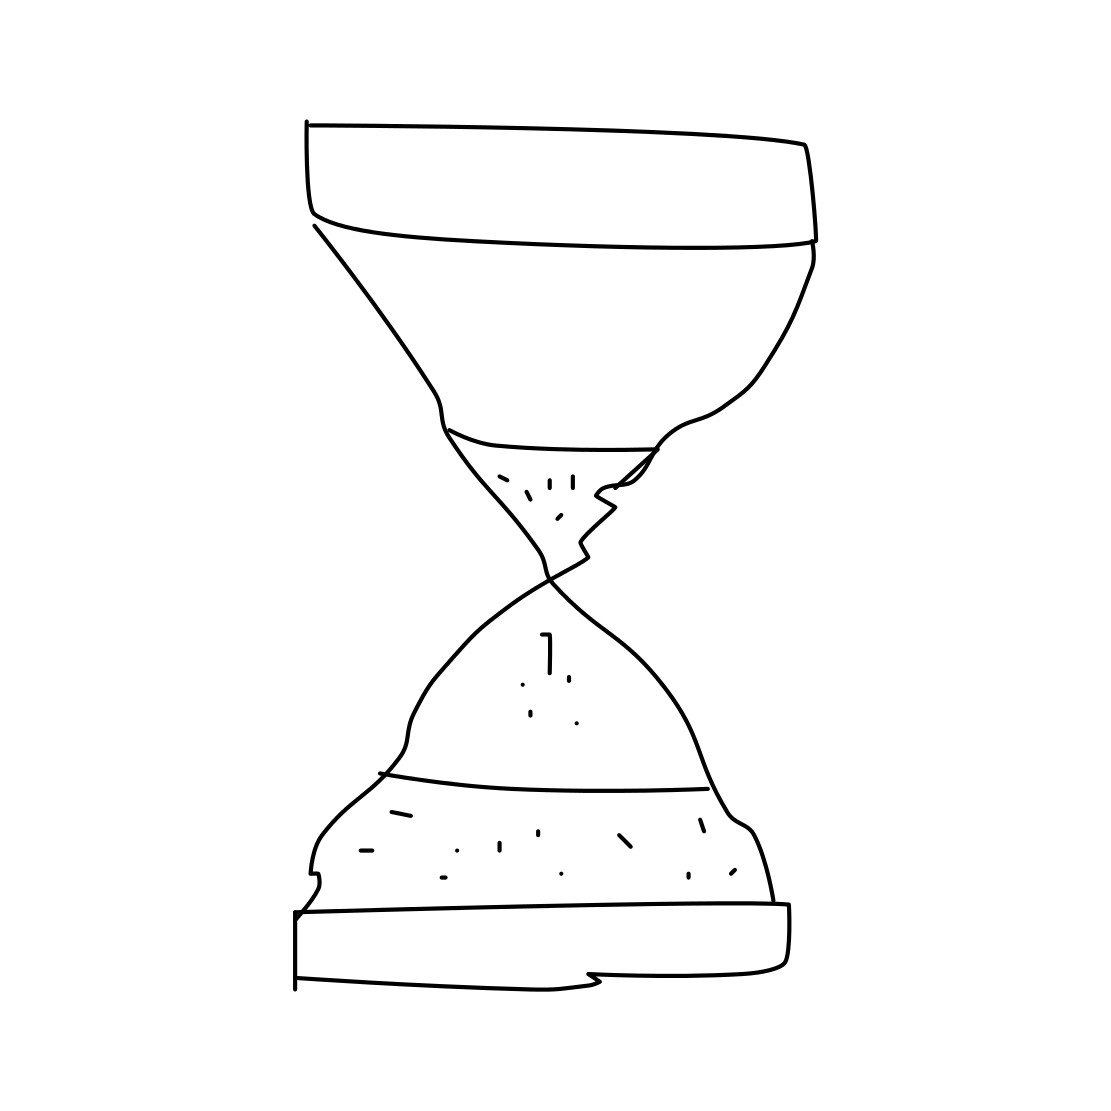Can you tell me what the hourglass is often used to represent symbolically? Certainly! The hourglass is frequently used as a symbol for the passage of time and its inevitability. It's often associated with the transience of life, the importance of pacing oneself, and reminds us that time is a finite resource. In history, art, and literature, an hourglass might be used to evoke themes of urgency, the temporal nature of existence, or the cycle of life and death. 